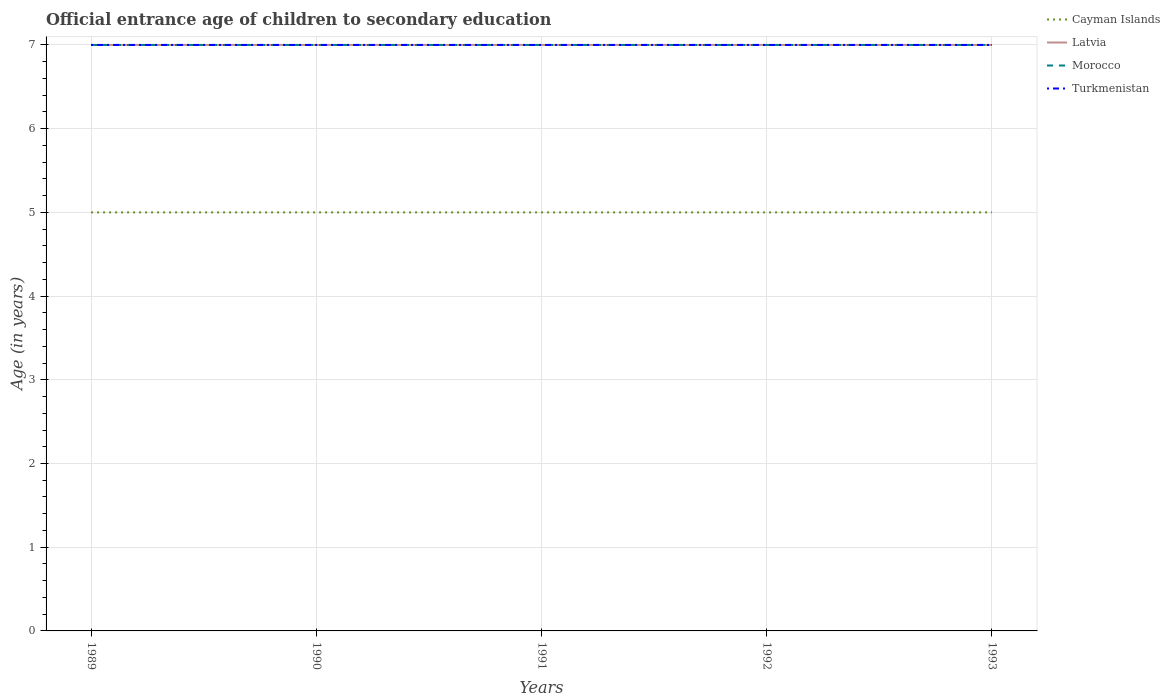How many different coloured lines are there?
Your answer should be very brief. 4. Does the line corresponding to Cayman Islands intersect with the line corresponding to Morocco?
Your answer should be very brief. No. Across all years, what is the maximum secondary school starting age of children in Morocco?
Make the answer very short. 7. What is the total secondary school starting age of children in Turkmenistan in the graph?
Offer a very short reply. 0. What is the difference between the highest and the second highest secondary school starting age of children in Turkmenistan?
Your response must be concise. 0. What is the difference between the highest and the lowest secondary school starting age of children in Cayman Islands?
Keep it short and to the point. 0. Is the secondary school starting age of children in Cayman Islands strictly greater than the secondary school starting age of children in Latvia over the years?
Your answer should be compact. Yes. How many lines are there?
Your answer should be compact. 4. Where does the legend appear in the graph?
Give a very brief answer. Top right. How many legend labels are there?
Give a very brief answer. 4. How are the legend labels stacked?
Keep it short and to the point. Vertical. What is the title of the graph?
Provide a succinct answer. Official entrance age of children to secondary education. Does "Sierra Leone" appear as one of the legend labels in the graph?
Make the answer very short. No. What is the label or title of the Y-axis?
Give a very brief answer. Age (in years). What is the Age (in years) in Latvia in 1989?
Your answer should be compact. 7. What is the Age (in years) of Latvia in 1990?
Your answer should be compact. 7. What is the Age (in years) in Turkmenistan in 1990?
Your response must be concise. 7. What is the Age (in years) of Cayman Islands in 1991?
Your response must be concise. 5. What is the Age (in years) in Morocco in 1991?
Ensure brevity in your answer.  7. What is the Age (in years) of Cayman Islands in 1993?
Make the answer very short. 5. What is the Age (in years) of Morocco in 1993?
Your response must be concise. 7. What is the Age (in years) in Turkmenistan in 1993?
Your response must be concise. 7. Across all years, what is the maximum Age (in years) of Cayman Islands?
Give a very brief answer. 5. Across all years, what is the maximum Age (in years) of Latvia?
Keep it short and to the point. 7. Across all years, what is the maximum Age (in years) of Morocco?
Your response must be concise. 7. Across all years, what is the minimum Age (in years) in Cayman Islands?
Provide a succinct answer. 5. What is the total Age (in years) of Turkmenistan in the graph?
Provide a short and direct response. 35. What is the difference between the Age (in years) of Latvia in 1989 and that in 1990?
Keep it short and to the point. 0. What is the difference between the Age (in years) of Turkmenistan in 1989 and that in 1990?
Your answer should be very brief. 0. What is the difference between the Age (in years) of Cayman Islands in 1989 and that in 1991?
Offer a terse response. 0. What is the difference between the Age (in years) in Latvia in 1989 and that in 1991?
Offer a terse response. 0. What is the difference between the Age (in years) in Morocco in 1989 and that in 1991?
Offer a very short reply. 0. What is the difference between the Age (in years) of Cayman Islands in 1989 and that in 1993?
Provide a short and direct response. 0. What is the difference between the Age (in years) in Latvia in 1989 and that in 1993?
Give a very brief answer. 0. What is the difference between the Age (in years) in Morocco in 1989 and that in 1993?
Provide a succinct answer. 0. What is the difference between the Age (in years) of Turkmenistan in 1989 and that in 1993?
Offer a terse response. 0. What is the difference between the Age (in years) in Cayman Islands in 1990 and that in 1991?
Make the answer very short. 0. What is the difference between the Age (in years) in Morocco in 1990 and that in 1991?
Ensure brevity in your answer.  0. What is the difference between the Age (in years) in Turkmenistan in 1990 and that in 1991?
Make the answer very short. 0. What is the difference between the Age (in years) of Cayman Islands in 1990 and that in 1992?
Provide a succinct answer. 0. What is the difference between the Age (in years) in Latvia in 1990 and that in 1992?
Give a very brief answer. 0. What is the difference between the Age (in years) of Morocco in 1990 and that in 1992?
Provide a succinct answer. 0. What is the difference between the Age (in years) of Turkmenistan in 1990 and that in 1993?
Offer a terse response. 0. What is the difference between the Age (in years) in Morocco in 1991 and that in 1992?
Your answer should be compact. 0. What is the difference between the Age (in years) in Morocco in 1991 and that in 1993?
Provide a short and direct response. 0. What is the difference between the Age (in years) in Cayman Islands in 1992 and that in 1993?
Offer a very short reply. 0. What is the difference between the Age (in years) of Morocco in 1992 and that in 1993?
Give a very brief answer. 0. What is the difference between the Age (in years) of Cayman Islands in 1989 and the Age (in years) of Morocco in 1990?
Your answer should be very brief. -2. What is the difference between the Age (in years) of Latvia in 1989 and the Age (in years) of Morocco in 1990?
Your response must be concise. 0. What is the difference between the Age (in years) in Morocco in 1989 and the Age (in years) in Turkmenistan in 1990?
Make the answer very short. 0. What is the difference between the Age (in years) of Cayman Islands in 1989 and the Age (in years) of Latvia in 1991?
Keep it short and to the point. -2. What is the difference between the Age (in years) of Morocco in 1989 and the Age (in years) of Turkmenistan in 1991?
Your answer should be compact. 0. What is the difference between the Age (in years) of Cayman Islands in 1989 and the Age (in years) of Turkmenistan in 1992?
Your answer should be very brief. -2. What is the difference between the Age (in years) of Latvia in 1989 and the Age (in years) of Turkmenistan in 1992?
Keep it short and to the point. 0. What is the difference between the Age (in years) in Cayman Islands in 1989 and the Age (in years) in Morocco in 1993?
Your answer should be very brief. -2. What is the difference between the Age (in years) in Morocco in 1989 and the Age (in years) in Turkmenistan in 1993?
Give a very brief answer. 0. What is the difference between the Age (in years) in Latvia in 1990 and the Age (in years) in Turkmenistan in 1991?
Give a very brief answer. 0. What is the difference between the Age (in years) in Cayman Islands in 1990 and the Age (in years) in Morocco in 1992?
Your answer should be compact. -2. What is the difference between the Age (in years) of Cayman Islands in 1990 and the Age (in years) of Turkmenistan in 1992?
Offer a terse response. -2. What is the difference between the Age (in years) in Latvia in 1990 and the Age (in years) in Turkmenistan in 1992?
Keep it short and to the point. 0. What is the difference between the Age (in years) in Cayman Islands in 1990 and the Age (in years) in Latvia in 1993?
Provide a succinct answer. -2. What is the difference between the Age (in years) in Latvia in 1990 and the Age (in years) in Turkmenistan in 1993?
Your answer should be compact. 0. What is the difference between the Age (in years) in Cayman Islands in 1991 and the Age (in years) in Latvia in 1992?
Your answer should be compact. -2. What is the difference between the Age (in years) in Cayman Islands in 1991 and the Age (in years) in Turkmenistan in 1992?
Keep it short and to the point. -2. What is the difference between the Age (in years) of Latvia in 1991 and the Age (in years) of Morocco in 1992?
Make the answer very short. 0. What is the difference between the Age (in years) in Morocco in 1991 and the Age (in years) in Turkmenistan in 1992?
Offer a terse response. 0. What is the difference between the Age (in years) of Latvia in 1991 and the Age (in years) of Morocco in 1993?
Your answer should be very brief. 0. What is the difference between the Age (in years) of Latvia in 1991 and the Age (in years) of Turkmenistan in 1993?
Ensure brevity in your answer.  0. What is the difference between the Age (in years) of Cayman Islands in 1992 and the Age (in years) of Turkmenistan in 1993?
Provide a short and direct response. -2. What is the average Age (in years) of Turkmenistan per year?
Provide a succinct answer. 7. In the year 1989, what is the difference between the Age (in years) in Cayman Islands and Age (in years) in Morocco?
Offer a very short reply. -2. In the year 1989, what is the difference between the Age (in years) in Cayman Islands and Age (in years) in Turkmenistan?
Offer a very short reply. -2. In the year 1989, what is the difference between the Age (in years) of Latvia and Age (in years) of Morocco?
Make the answer very short. 0. In the year 1989, what is the difference between the Age (in years) of Latvia and Age (in years) of Turkmenistan?
Your answer should be very brief. 0. In the year 1990, what is the difference between the Age (in years) in Cayman Islands and Age (in years) in Morocco?
Your response must be concise. -2. In the year 1991, what is the difference between the Age (in years) of Cayman Islands and Age (in years) of Turkmenistan?
Your answer should be compact. -2. In the year 1991, what is the difference between the Age (in years) in Morocco and Age (in years) in Turkmenistan?
Keep it short and to the point. 0. In the year 1992, what is the difference between the Age (in years) of Cayman Islands and Age (in years) of Morocco?
Your answer should be very brief. -2. In the year 1993, what is the difference between the Age (in years) of Cayman Islands and Age (in years) of Latvia?
Keep it short and to the point. -2. In the year 1993, what is the difference between the Age (in years) of Cayman Islands and Age (in years) of Morocco?
Keep it short and to the point. -2. In the year 1993, what is the difference between the Age (in years) in Latvia and Age (in years) in Morocco?
Provide a short and direct response. 0. In the year 1993, what is the difference between the Age (in years) in Morocco and Age (in years) in Turkmenistan?
Offer a terse response. 0. What is the ratio of the Age (in years) of Morocco in 1989 to that in 1990?
Provide a succinct answer. 1. What is the ratio of the Age (in years) of Turkmenistan in 1989 to that in 1990?
Give a very brief answer. 1. What is the ratio of the Age (in years) of Latvia in 1989 to that in 1991?
Offer a terse response. 1. What is the ratio of the Age (in years) of Morocco in 1989 to that in 1991?
Offer a terse response. 1. What is the ratio of the Age (in years) of Morocco in 1989 to that in 1992?
Keep it short and to the point. 1. What is the ratio of the Age (in years) of Cayman Islands in 1989 to that in 1993?
Offer a terse response. 1. What is the ratio of the Age (in years) in Cayman Islands in 1990 to that in 1991?
Ensure brevity in your answer.  1. What is the ratio of the Age (in years) of Cayman Islands in 1990 to that in 1992?
Provide a succinct answer. 1. What is the ratio of the Age (in years) of Turkmenistan in 1990 to that in 1992?
Give a very brief answer. 1. What is the ratio of the Age (in years) in Cayman Islands in 1990 to that in 1993?
Keep it short and to the point. 1. What is the ratio of the Age (in years) in Latvia in 1990 to that in 1993?
Your response must be concise. 1. What is the ratio of the Age (in years) of Turkmenistan in 1990 to that in 1993?
Keep it short and to the point. 1. What is the ratio of the Age (in years) in Latvia in 1991 to that in 1992?
Ensure brevity in your answer.  1. What is the ratio of the Age (in years) of Morocco in 1991 to that in 1992?
Your response must be concise. 1. What is the ratio of the Age (in years) in Latvia in 1991 to that in 1993?
Make the answer very short. 1. What is the ratio of the Age (in years) of Morocco in 1992 to that in 1993?
Provide a succinct answer. 1. What is the ratio of the Age (in years) in Turkmenistan in 1992 to that in 1993?
Your answer should be very brief. 1. What is the difference between the highest and the second highest Age (in years) of Cayman Islands?
Keep it short and to the point. 0. What is the difference between the highest and the second highest Age (in years) of Latvia?
Offer a very short reply. 0. What is the difference between the highest and the lowest Age (in years) of Latvia?
Your answer should be compact. 0. What is the difference between the highest and the lowest Age (in years) of Morocco?
Your response must be concise. 0. What is the difference between the highest and the lowest Age (in years) in Turkmenistan?
Provide a short and direct response. 0. 